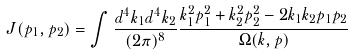<formula> <loc_0><loc_0><loc_500><loc_500>J ( p _ { 1 } , p _ { 2 } ) = \int \frac { d ^ { 4 } k _ { 1 } d ^ { 4 } k _ { 2 } } { ( 2 \pi ) ^ { 8 } } \frac { k ^ { 2 } _ { 1 } p ^ { 2 } _ { 1 } + k ^ { 2 } _ { 2 } p ^ { 2 } _ { 2 } - 2 k _ { 1 } k _ { 2 } p _ { 1 } p _ { 2 } } { \Omega ( k , p ) }</formula> 